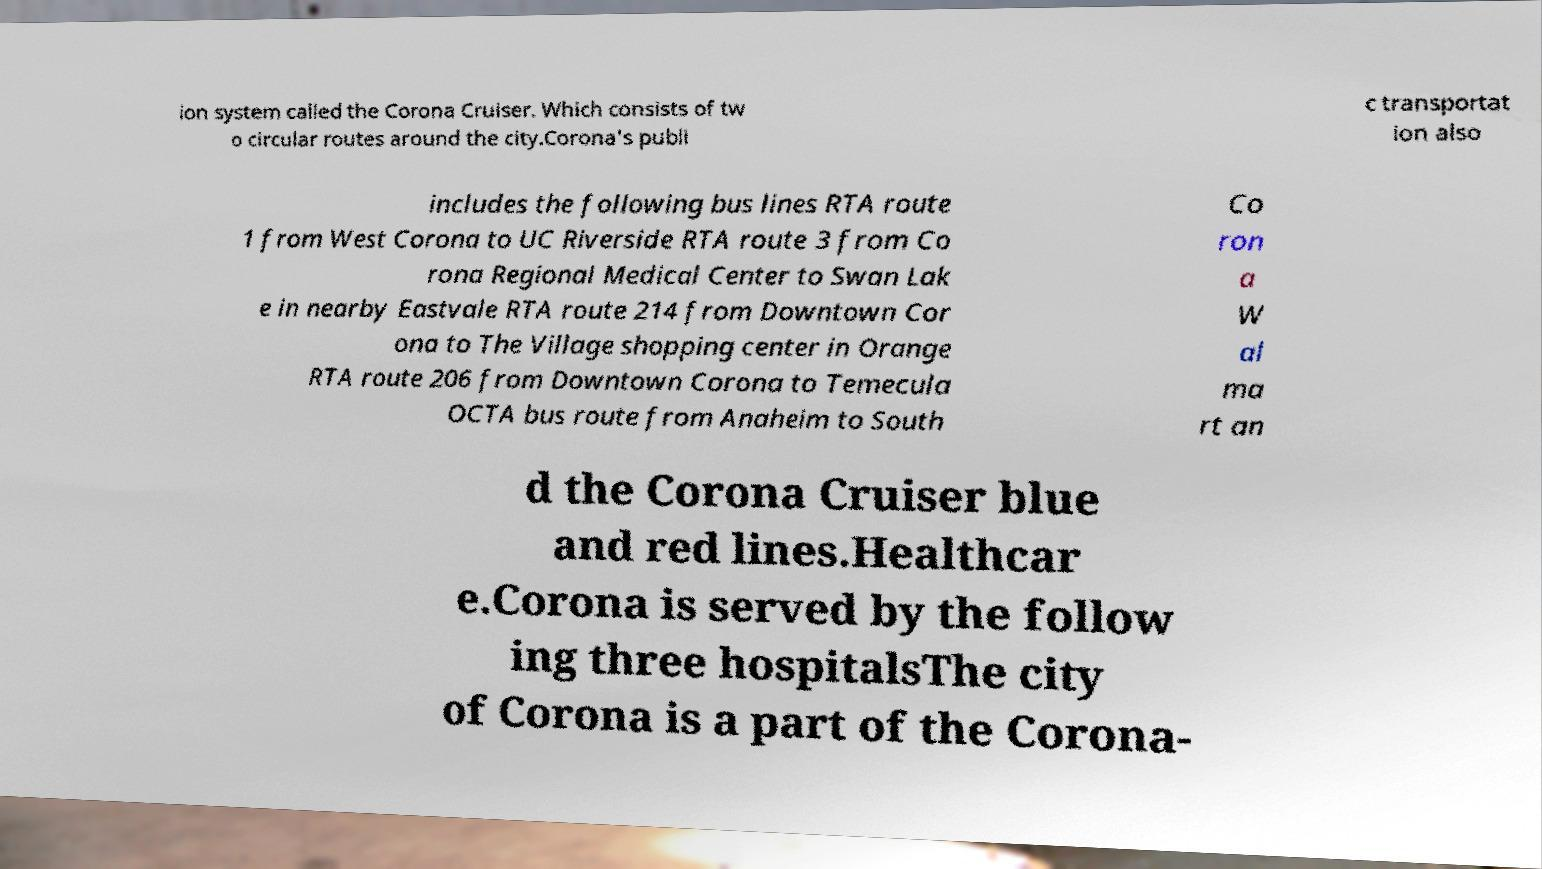There's text embedded in this image that I need extracted. Can you transcribe it verbatim? ion system called the Corona Cruiser. Which consists of tw o circular routes around the city.Corona's publi c transportat ion also includes the following bus lines RTA route 1 from West Corona to UC Riverside RTA route 3 from Co rona Regional Medical Center to Swan Lak e in nearby Eastvale RTA route 214 from Downtown Cor ona to The Village shopping center in Orange RTA route 206 from Downtown Corona to Temecula OCTA bus route from Anaheim to South Co ron a W al ma rt an d the Corona Cruiser blue and red lines.Healthcar e.Corona is served by the follow ing three hospitalsThe city of Corona is a part of the Corona- 